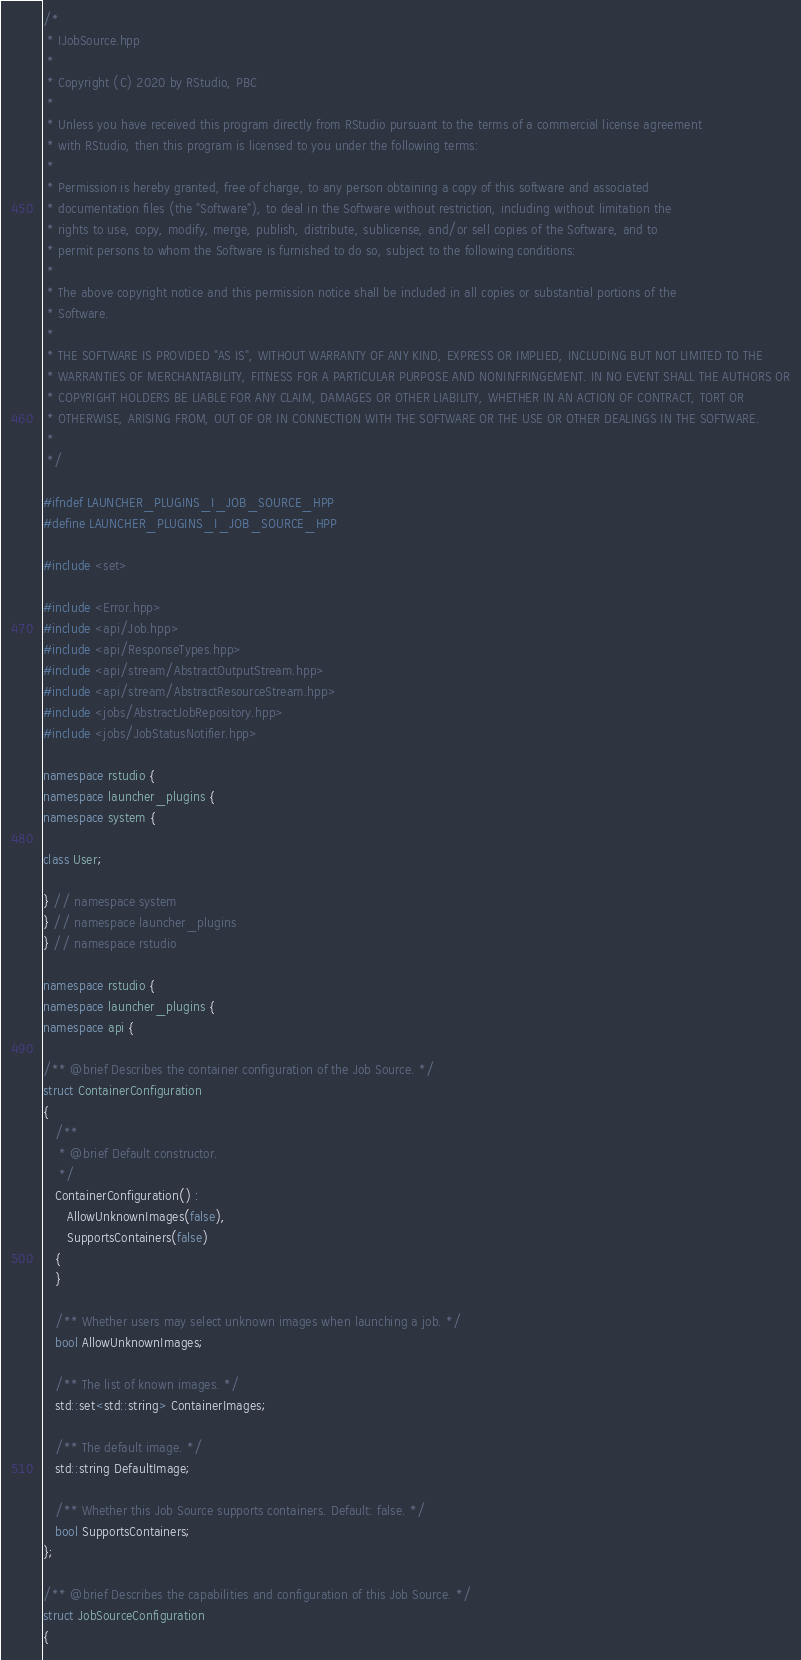<code> <loc_0><loc_0><loc_500><loc_500><_C++_>/*
 * IJobSource.hpp
 *
 * Copyright (C) 2020 by RStudio, PBC
 *
 * Unless you have received this program directly from RStudio pursuant to the terms of a commercial license agreement
 * with RStudio, then this program is licensed to you under the following terms:
 *
 * Permission is hereby granted, free of charge, to any person obtaining a copy of this software and associated
 * documentation files (the "Software"), to deal in the Software without restriction, including without limitation the
 * rights to use, copy, modify, merge, publish, distribute, sublicense, and/or sell copies of the Software, and to
 * permit persons to whom the Software is furnished to do so, subject to the following conditions:
 *
 * The above copyright notice and this permission notice shall be included in all copies or substantial portions of the
 * Software.
 *
 * THE SOFTWARE IS PROVIDED "AS IS", WITHOUT WARRANTY OF ANY KIND, EXPRESS OR IMPLIED, INCLUDING BUT NOT LIMITED TO THE
 * WARRANTIES OF MERCHANTABILITY, FITNESS FOR A PARTICULAR PURPOSE AND NONINFRINGEMENT. IN NO EVENT SHALL THE AUTHORS OR
 * COPYRIGHT HOLDERS BE LIABLE FOR ANY CLAIM, DAMAGES OR OTHER LIABILITY, WHETHER IN AN ACTION OF CONTRACT, TORT OR
 * OTHERWISE, ARISING FROM, OUT OF OR IN CONNECTION WITH THE SOFTWARE OR THE USE OR OTHER DEALINGS IN THE SOFTWARE.
 *
 */

#ifndef LAUNCHER_PLUGINS_I_JOB_SOURCE_HPP
#define LAUNCHER_PLUGINS_I_JOB_SOURCE_HPP

#include <set>

#include <Error.hpp>
#include <api/Job.hpp>
#include <api/ResponseTypes.hpp>
#include <api/stream/AbstractOutputStream.hpp>
#include <api/stream/AbstractResourceStream.hpp>
#include <jobs/AbstractJobRepository.hpp>
#include <jobs/JobStatusNotifier.hpp>

namespace rstudio {
namespace launcher_plugins {
namespace system {

class User;

} // namespace system
} // namespace launcher_plugins
} // namespace rstudio

namespace rstudio {
namespace launcher_plugins {
namespace api {

/** @brief Describes the container configuration of the Job Source. */
struct ContainerConfiguration
{
   /**
    * @brief Default constructor.
    */
   ContainerConfiguration() :
      AllowUnknownImages(false),
      SupportsContainers(false)
   {
   }

   /** Whether users may select unknown images when launching a job. */
   bool AllowUnknownImages;

   /** The list of known images. */
   std::set<std::string> ContainerImages;

   /** The default image. */
   std::string DefaultImage;

   /** Whether this Job Source supports containers. Default: false. */
   bool SupportsContainers;
};

/** @brief Describes the capabilities and configuration of this Job Source. */
struct JobSourceConfiguration
{</code> 